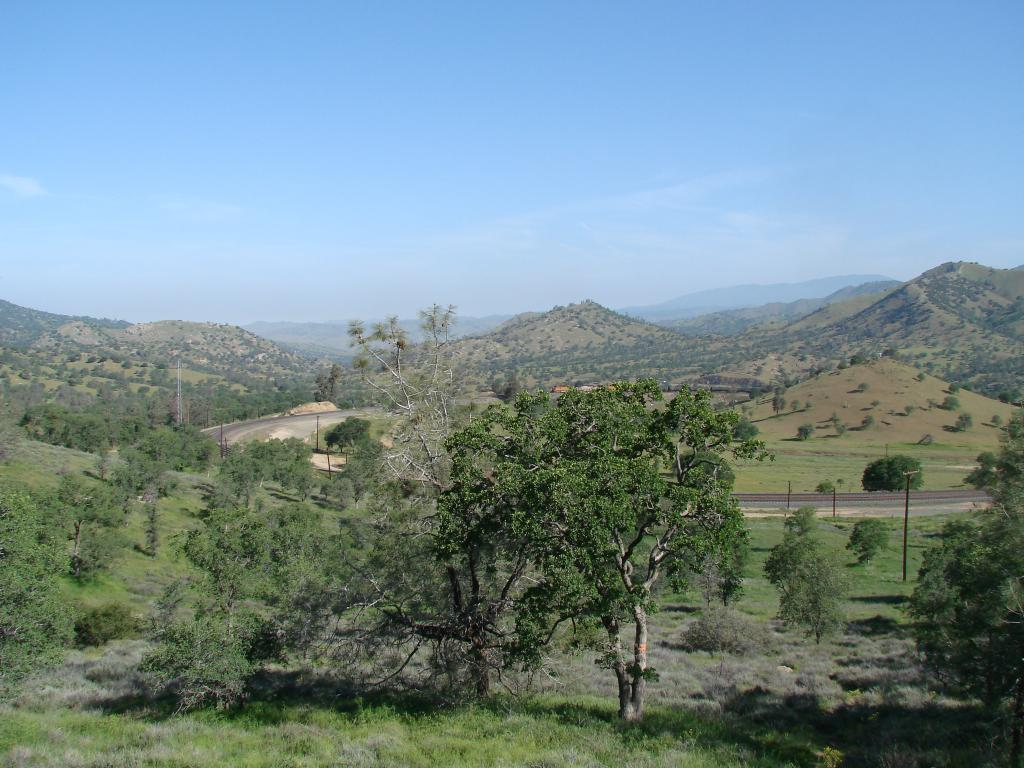What type of vegetation can be seen in the image? There are trees, grass, and plants in the image. What type of terrain is visible in the image? There are hills in the image. What man-made structure is present in the image? There is a road in the image. What else can be seen in the image besides the vegetation and terrain? There are poles in the image. What is visible in the background of the image? The sky is visible in the background of the image. What type of gold jewelry is the beast wearing in the image? There is no beast or gold jewelry present in the image. 